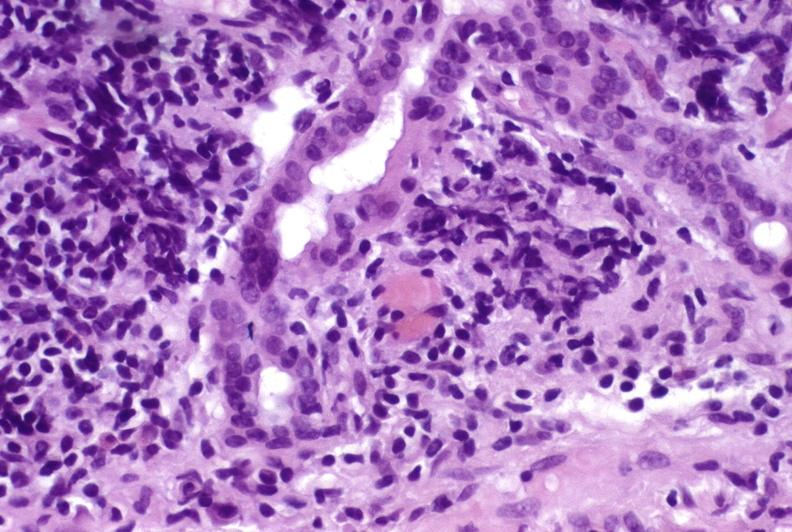s hepatobiliary present?
Answer the question using a single word or phrase. Yes 